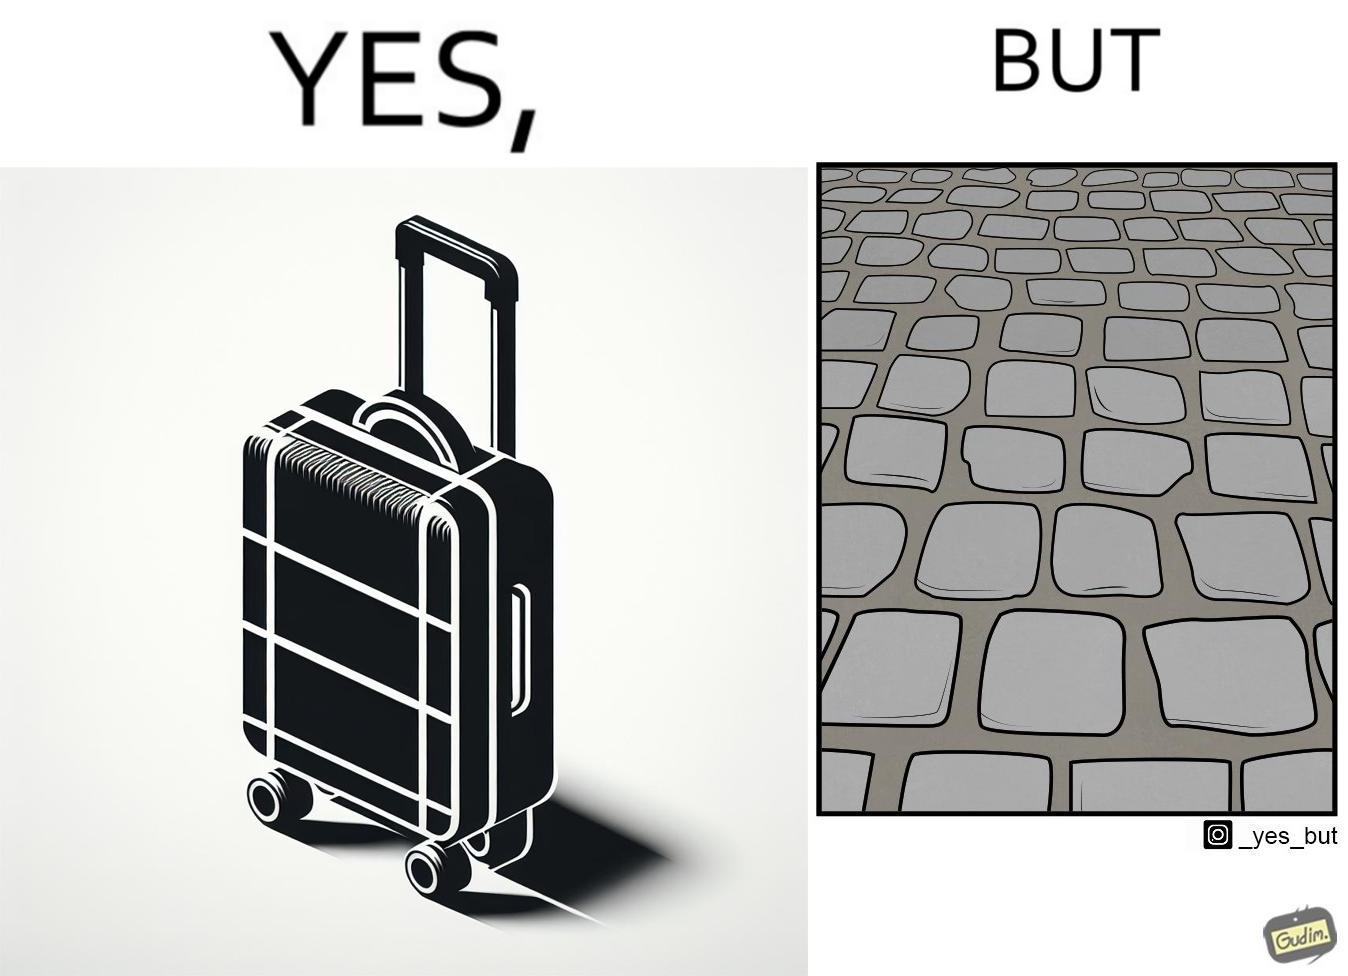Describe the satirical element in this image. The image is funny because even though the trolley bag is made to make carrying luggage easy, as soon as it encounters a rough surface like cobblestone road, it makes carrying luggage more difficult. 